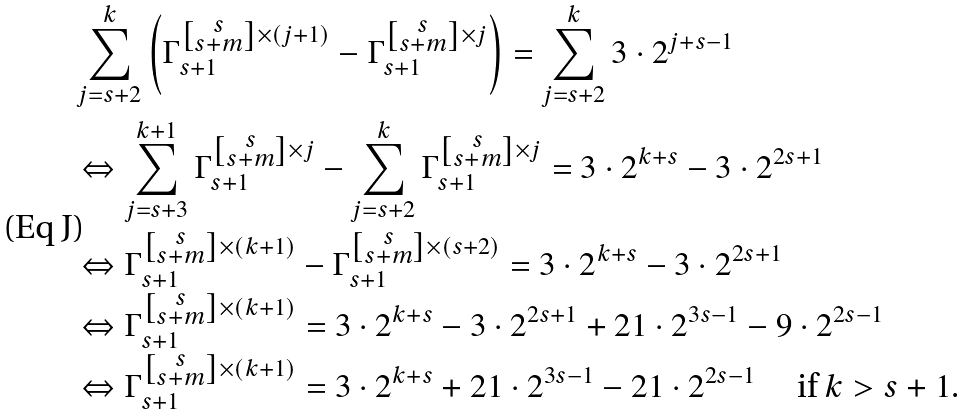<formula> <loc_0><loc_0><loc_500><loc_500>& \sum _ { j = s + 2 } ^ { k } \left ( \Gamma _ { s + 1 } ^ { \left [ \substack { s \\ s + m } \right ] \times ( j + 1 ) } - \Gamma _ { s + 1 } ^ { \left [ \substack { s \\ s + m } \right ] \times j } \right ) = \sum _ { j = s + 2 } ^ { k } 3 \cdot 2 ^ { j + s - 1 } \\ & \Leftrightarrow \sum _ { j = s + 3 } ^ { k + 1 } \Gamma _ { s + 1 } ^ { \left [ \substack { s \\ s + m } \right ] \times j } - \sum _ { j = s + 2 } ^ { k } \Gamma _ { s + 1 } ^ { \left [ \substack { s \\ s + m } \right ] \times j } = 3 \cdot 2 ^ { k + s } - 3 \cdot 2 ^ { 2 s + 1 } \\ & \Leftrightarrow \Gamma _ { s + 1 } ^ { \left [ \substack { s \\ s + m } \right ] \times ( k + 1 ) } - \Gamma _ { s + 1 } ^ { \left [ \substack { s \\ s + m } \right ] \times ( s + 2 ) } = 3 \cdot 2 ^ { k + s } - 3 \cdot 2 ^ { 2 s + 1 } \\ & \Leftrightarrow \Gamma _ { s + 1 } ^ { \left [ \substack { s \\ s + m } \right ] \times ( k + 1 ) } = 3 \cdot 2 ^ { k + s } - 3 \cdot 2 ^ { 2 s + 1 } + 2 1 \cdot 2 ^ { 3 s - 1 } - 9 \cdot 2 ^ { 2 s - 1 } \\ & \Leftrightarrow \Gamma _ { s + 1 } ^ { \left [ \substack { s \\ s + m } \right ] \times ( k + 1 ) } = 3 \cdot 2 ^ { k + s } + 2 1 \cdot 2 ^ { 3 s - 1 } - 2 1 \cdot 2 ^ { 2 s - 1 } \quad \text { if $ k > s+1 $} . \\ &</formula> 